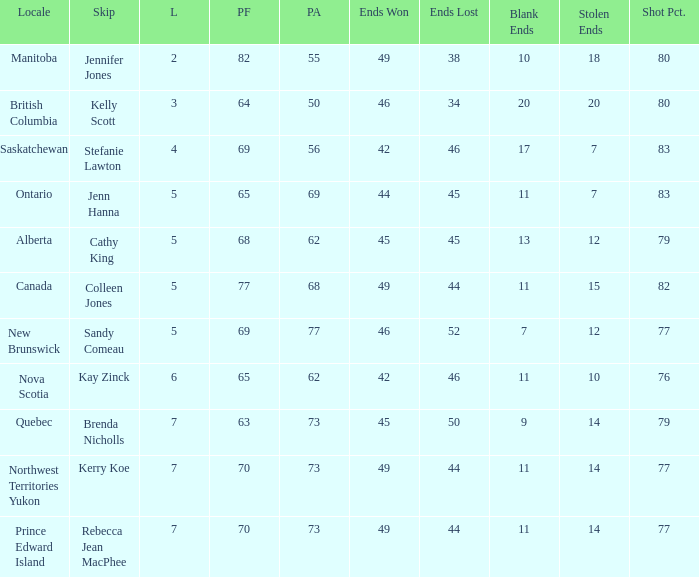Help me parse the entirety of this table. {'header': ['Locale', 'Skip', 'L', 'PF', 'PA', 'Ends Won', 'Ends Lost', 'Blank Ends', 'Stolen Ends', 'Shot Pct.'], 'rows': [['Manitoba', 'Jennifer Jones', '2', '82', '55', '49', '38', '10', '18', '80'], ['British Columbia', 'Kelly Scott', '3', '64', '50', '46', '34', '20', '20', '80'], ['Saskatchewan', 'Stefanie Lawton', '4', '69', '56', '42', '46', '17', '7', '83'], ['Ontario', 'Jenn Hanna', '5', '65', '69', '44', '45', '11', '7', '83'], ['Alberta', 'Cathy King', '5', '68', '62', '45', '45', '13', '12', '79'], ['Canada', 'Colleen Jones', '5', '77', '68', '49', '44', '11', '15', '82'], ['New Brunswick', 'Sandy Comeau', '5', '69', '77', '46', '52', '7', '12', '77'], ['Nova Scotia', 'Kay Zinck', '6', '65', '62', '42', '46', '11', '10', '76'], ['Quebec', 'Brenda Nicholls', '7', '63', '73', '45', '50', '9', '14', '79'], ['Northwest Territories Yukon', 'Kerry Koe', '7', '70', '73', '49', '44', '11', '14', '77'], ['Prince Edward Island', 'Rebecca Jean MacPhee', '7', '70', '73', '49', '44', '11', '14', '77']]} What is the minimum PA when ends lost is 45? 62.0. 